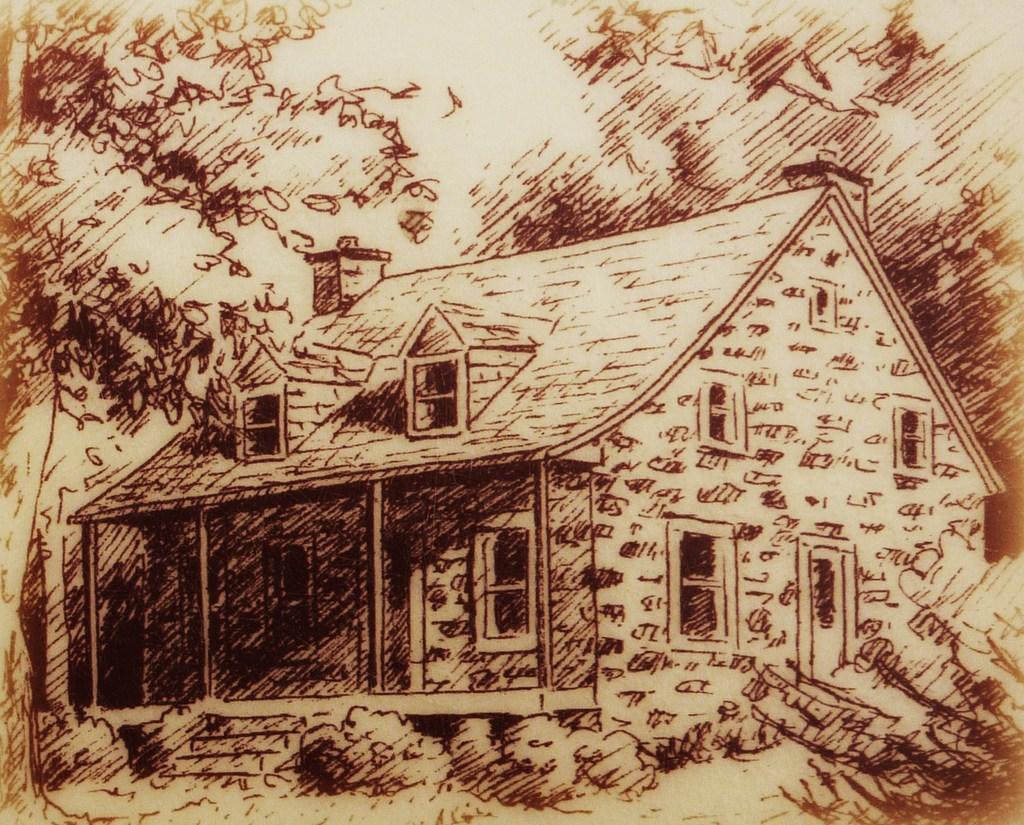Describe this image in one or two sentences. In this image we can see the depiction of a house, stairs, plants and also the tree. 